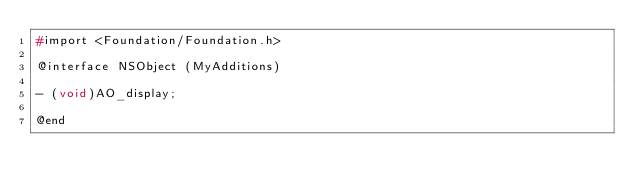Convert code to text. <code><loc_0><loc_0><loc_500><loc_500><_C_>#import <Foundation/Foundation.h>

@interface NSObject (MyAdditions)

- (void)AO_display;

@end
</code> 